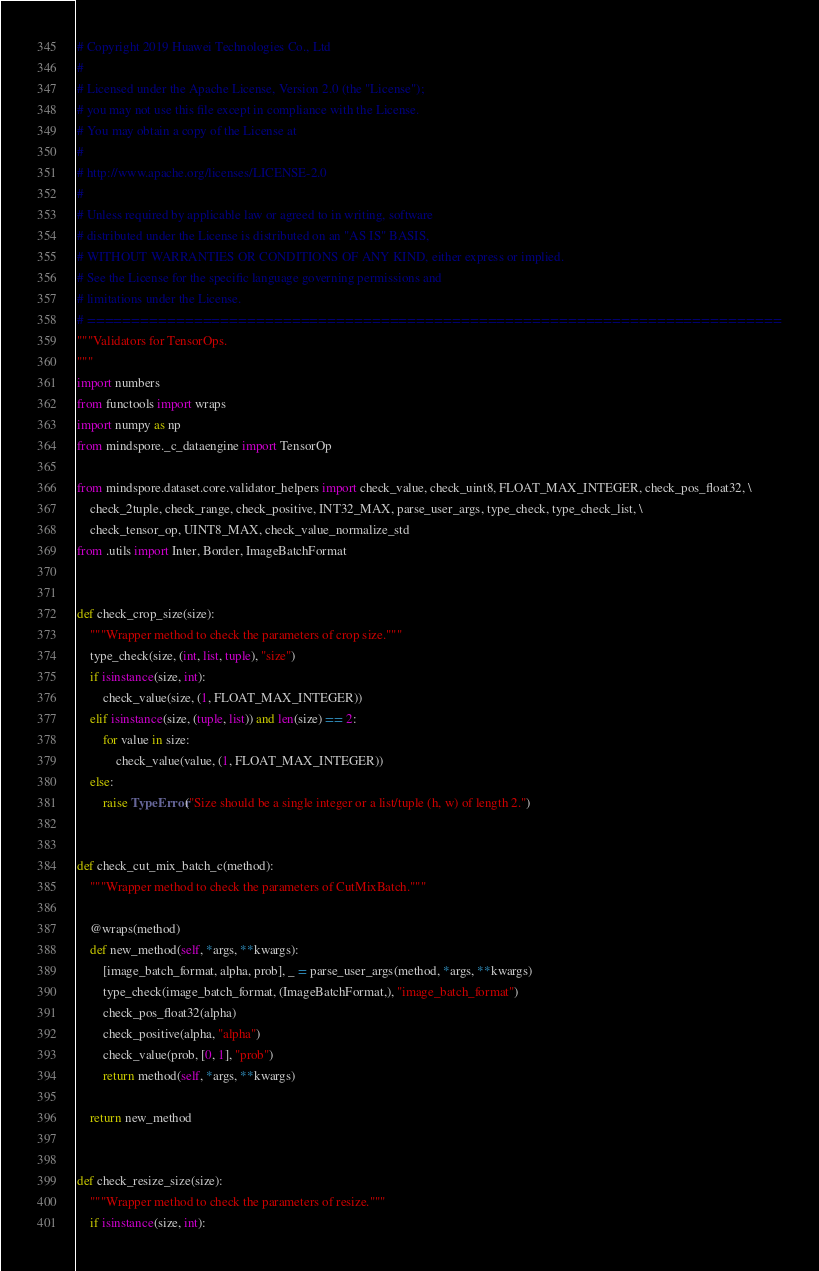Convert code to text. <code><loc_0><loc_0><loc_500><loc_500><_Python_># Copyright 2019 Huawei Technologies Co., Ltd
#
# Licensed under the Apache License, Version 2.0 (the "License");
# you may not use this file except in compliance with the License.
# You may obtain a copy of the License at
#
# http://www.apache.org/licenses/LICENSE-2.0
#
# Unless required by applicable law or agreed to in writing, software
# distributed under the License is distributed on an "AS IS" BASIS,
# WITHOUT WARRANTIES OR CONDITIONS OF ANY KIND, either express or implied.
# See the License for the specific language governing permissions and
# limitations under the License.
# ==============================================================================
"""Validators for TensorOps.
"""
import numbers
from functools import wraps
import numpy as np
from mindspore._c_dataengine import TensorOp

from mindspore.dataset.core.validator_helpers import check_value, check_uint8, FLOAT_MAX_INTEGER, check_pos_float32, \
    check_2tuple, check_range, check_positive, INT32_MAX, parse_user_args, type_check, type_check_list, \
    check_tensor_op, UINT8_MAX, check_value_normalize_std
from .utils import Inter, Border, ImageBatchFormat


def check_crop_size(size):
    """Wrapper method to check the parameters of crop size."""
    type_check(size, (int, list, tuple), "size")
    if isinstance(size, int):
        check_value(size, (1, FLOAT_MAX_INTEGER))
    elif isinstance(size, (tuple, list)) and len(size) == 2:
        for value in size:
            check_value(value, (1, FLOAT_MAX_INTEGER))
    else:
        raise TypeError("Size should be a single integer or a list/tuple (h, w) of length 2.")


def check_cut_mix_batch_c(method):
    """Wrapper method to check the parameters of CutMixBatch."""

    @wraps(method)
    def new_method(self, *args, **kwargs):
        [image_batch_format, alpha, prob], _ = parse_user_args(method, *args, **kwargs)
        type_check(image_batch_format, (ImageBatchFormat,), "image_batch_format")
        check_pos_float32(alpha)
        check_positive(alpha, "alpha")
        check_value(prob, [0, 1], "prob")
        return method(self, *args, **kwargs)

    return new_method


def check_resize_size(size):
    """Wrapper method to check the parameters of resize."""
    if isinstance(size, int):</code> 